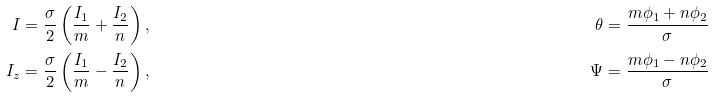<formula> <loc_0><loc_0><loc_500><loc_500>I & = \frac { \sigma } { 2 } \left ( \frac { I _ { 1 } } { m } + \frac { I _ { 2 } } { n } \right ) , & \theta & = \frac { m \phi _ { 1 } + n \phi _ { 2 } } { \sigma } \\ I _ { z } & = \frac { \sigma } { 2 } \left ( \frac { I _ { 1 } } { m } - \frac { I _ { 2 } } { n } \right ) , & \Psi & = \frac { m \phi _ { 1 } - n \phi _ { 2 } } { \sigma }</formula> 